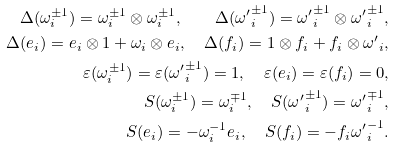<formula> <loc_0><loc_0><loc_500><loc_500>\Delta ( \omega _ { i } ^ { \pm 1 } ) = \omega _ { i } ^ { \pm 1 } \otimes \omega _ { i } ^ { \pm 1 } , \quad \Delta ( { \omega ^ { \prime } } _ { i } ^ { \pm 1 } ) = { \omega ^ { \prime } } _ { i } ^ { \pm 1 } \otimes { \omega ^ { \prime } } _ { i } ^ { \pm 1 } , \\ \Delta ( e _ { i } ) = e _ { i } \otimes 1 + \omega _ { i } \otimes e _ { i } , \quad \Delta ( f _ { i } ) = 1 \otimes f _ { i } + f _ { i } \otimes { \omega ^ { \prime } } _ { i } , \\ \varepsilon ( \omega _ { i } ^ { \pm 1 } ) = \varepsilon ( { \omega ^ { \prime } } _ { i } ^ { \pm 1 } ) = 1 , \quad \varepsilon ( e _ { i } ) = \varepsilon ( f _ { i } ) = 0 , \\ S ( \omega _ { i } ^ { \pm 1 } ) = \omega _ { i } ^ { \mp 1 } , \quad S ( { \omega ^ { \prime } } _ { i } ^ { \pm 1 } ) = { \omega ^ { \prime } } _ { i } ^ { \mp 1 } , \\ S ( e _ { i } ) = - \omega _ { i } ^ { - 1 } e _ { i } , \quad S ( f _ { i } ) = - f _ { i } { \omega ^ { \prime } } _ { i } ^ { - 1 } .</formula> 